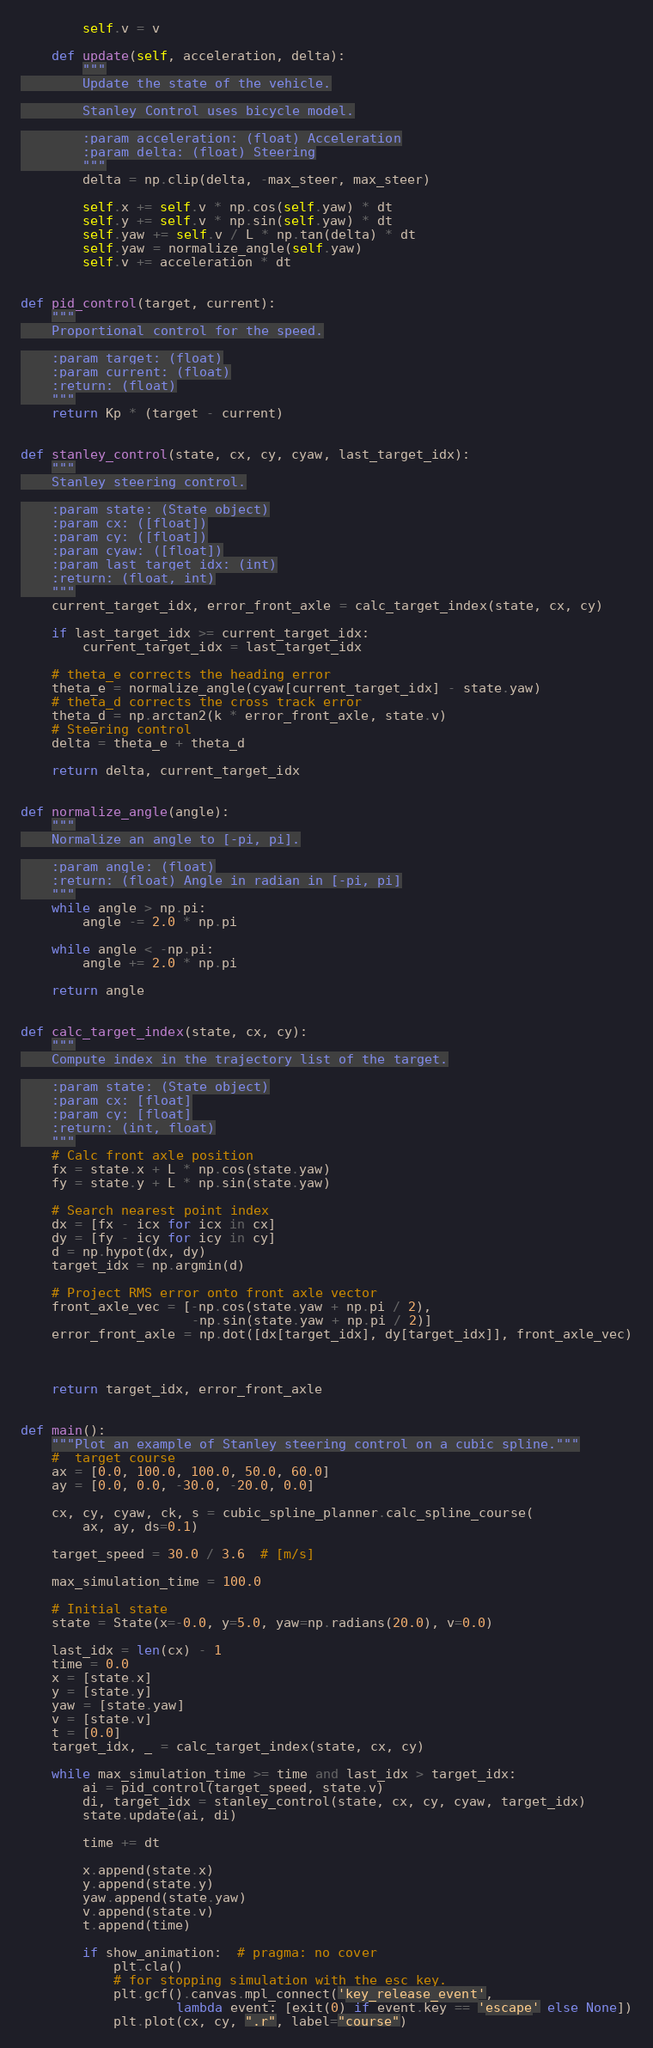<code> <loc_0><loc_0><loc_500><loc_500><_Python_>        self.v = v

    def update(self, acceleration, delta):
        """
        Update the state of the vehicle.

        Stanley Control uses bicycle model.

        :param acceleration: (float) Acceleration
        :param delta: (float) Steering
        """
        delta = np.clip(delta, -max_steer, max_steer)

        self.x += self.v * np.cos(self.yaw) * dt
        self.y += self.v * np.sin(self.yaw) * dt
        self.yaw += self.v / L * np.tan(delta) * dt
        self.yaw = normalize_angle(self.yaw)
        self.v += acceleration * dt


def pid_control(target, current):
    """
    Proportional control for the speed.

    :param target: (float)
    :param current: (float)
    :return: (float)
    """
    return Kp * (target - current)


def stanley_control(state, cx, cy, cyaw, last_target_idx):
    """
    Stanley steering control.

    :param state: (State object)
    :param cx: ([float])
    :param cy: ([float])
    :param cyaw: ([float])
    :param last_target_idx: (int)
    :return: (float, int)
    """
    current_target_idx, error_front_axle = calc_target_index(state, cx, cy)

    if last_target_idx >= current_target_idx:
        current_target_idx = last_target_idx

    # theta_e corrects the heading error
    theta_e = normalize_angle(cyaw[current_target_idx] - state.yaw)
    # theta_d corrects the cross track error
    theta_d = np.arctan2(k * error_front_axle, state.v)
    # Steering control
    delta = theta_e + theta_d

    return delta, current_target_idx


def normalize_angle(angle):
    """
    Normalize an angle to [-pi, pi].

    :param angle: (float)
    :return: (float) Angle in radian in [-pi, pi]
    """
    while angle > np.pi:
        angle -= 2.0 * np.pi

    while angle < -np.pi:
        angle += 2.0 * np.pi

    return angle


def calc_target_index(state, cx, cy):
    """
    Compute index in the trajectory list of the target.

    :param state: (State object)
    :param cx: [float]
    :param cy: [float]
    :return: (int, float)
    """
    # Calc front axle position
    fx = state.x + L * np.cos(state.yaw)
    fy = state.y + L * np.sin(state.yaw)

    # Search nearest point index
    dx = [fx - icx for icx in cx]
    dy = [fy - icy for icy in cy]
    d = np.hypot(dx, dy)
    target_idx = np.argmin(d)

    # Project RMS error onto front axle vector
    front_axle_vec = [-np.cos(state.yaw + np.pi / 2),
                      -np.sin(state.yaw + np.pi / 2)]
    error_front_axle = np.dot([dx[target_idx], dy[target_idx]], front_axle_vec)



    return target_idx, error_front_axle


def main():
    """Plot an example of Stanley steering control on a cubic spline."""
    #  target course
    ax = [0.0, 100.0, 100.0, 50.0, 60.0]
    ay = [0.0, 0.0, -30.0, -20.0, 0.0]

    cx, cy, cyaw, ck, s = cubic_spline_planner.calc_spline_course(
        ax, ay, ds=0.1)

    target_speed = 30.0 / 3.6  # [m/s]

    max_simulation_time = 100.0

    # Initial state
    state = State(x=-0.0, y=5.0, yaw=np.radians(20.0), v=0.0)

    last_idx = len(cx) - 1
    time = 0.0
    x = [state.x]
    y = [state.y]
    yaw = [state.yaw]
    v = [state.v]
    t = [0.0]
    target_idx, _ = calc_target_index(state, cx, cy)

    while max_simulation_time >= time and last_idx > target_idx:
        ai = pid_control(target_speed, state.v)
        di, target_idx = stanley_control(state, cx, cy, cyaw, target_idx)
        state.update(ai, di)

        time += dt

        x.append(state.x)
        y.append(state.y)
        yaw.append(state.yaw)
        v.append(state.v)
        t.append(time)

        if show_animation:  # pragma: no cover
            plt.cla()
            # for stopping simulation with the esc key.
            plt.gcf().canvas.mpl_connect('key_release_event',
                    lambda event: [exit(0) if event.key == 'escape' else None])
            plt.plot(cx, cy, ".r", label="course")</code> 